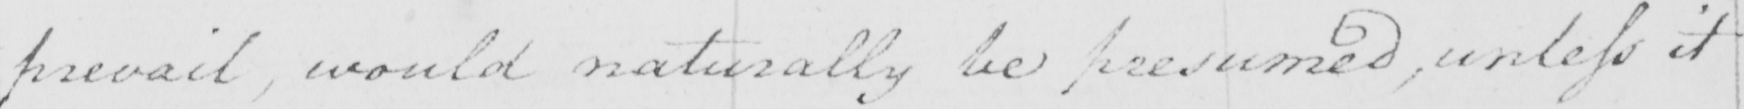Can you tell me what this handwritten text says? prevail , would naturally be presumed , unless it 